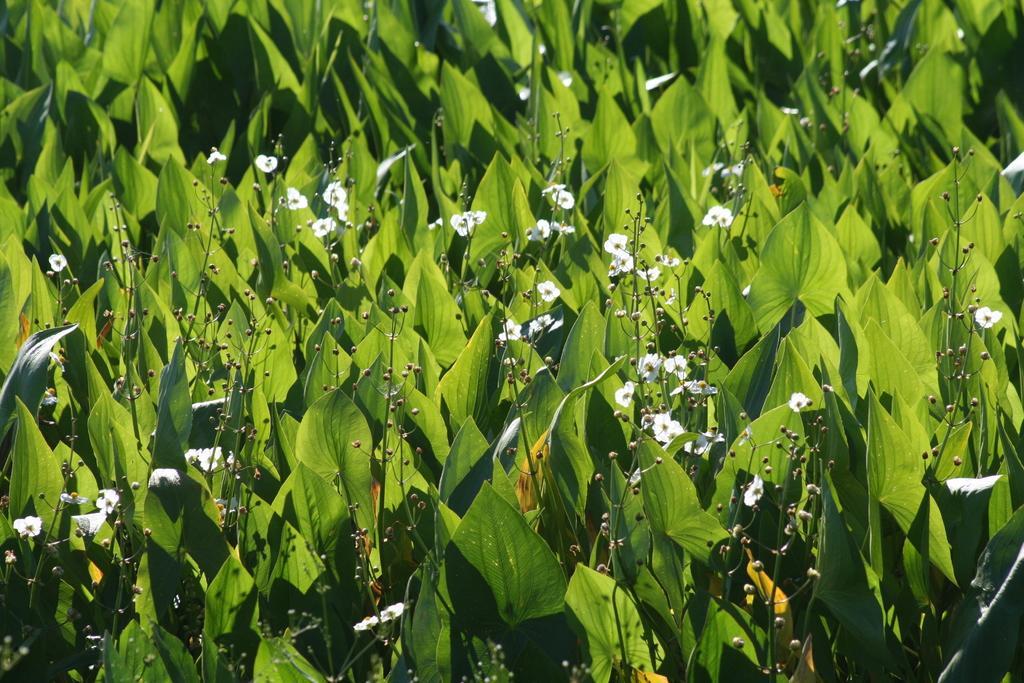Could you give a brief overview of what you see in this image? In this image, we can see so many plants, green leaves, flowers and stems. 